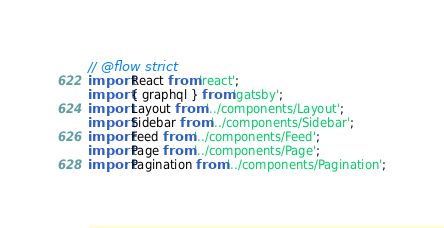Convert code to text. <code><loc_0><loc_0><loc_500><loc_500><_JavaScript_>// @flow strict
import React from 'react';
import { graphql } from 'gatsby';
import Layout from '../components/Layout';
import Sidebar from '../components/Sidebar';
import Feed from '../components/Feed';
import Page from '../components/Page';
import Pagination from '../components/Pagination';</code> 